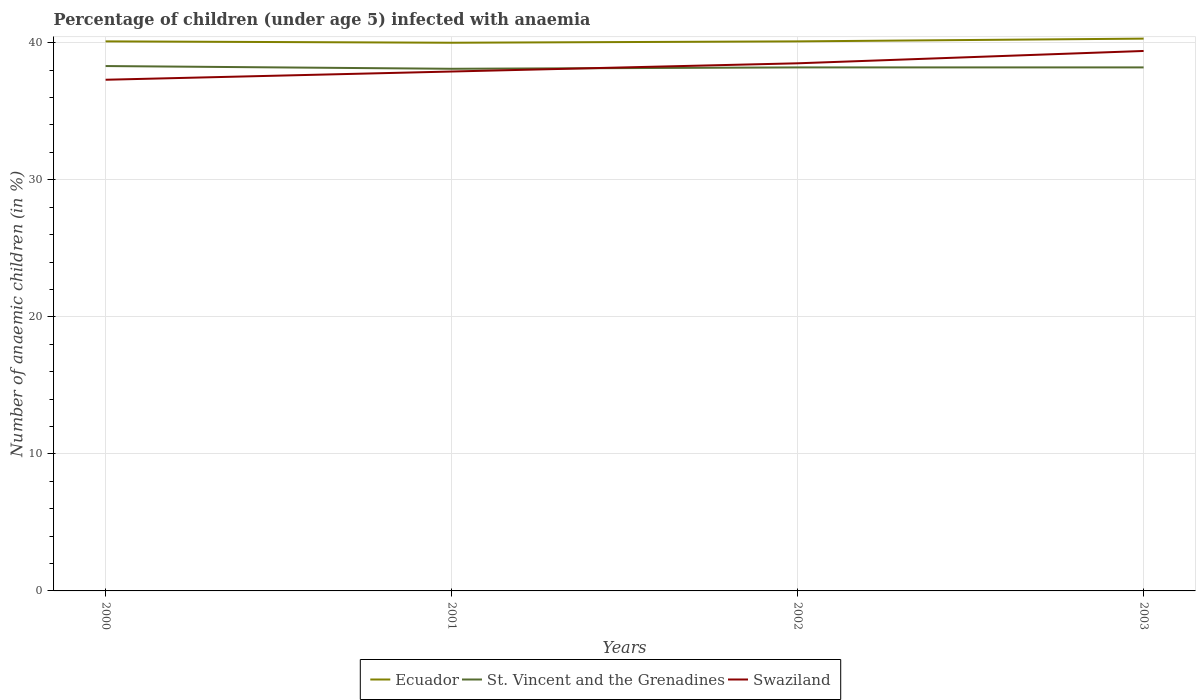Does the line corresponding to St. Vincent and the Grenadines intersect with the line corresponding to Swaziland?
Provide a short and direct response. Yes. Is the number of lines equal to the number of legend labels?
Provide a succinct answer. Yes. Across all years, what is the maximum percentage of children infected with anaemia in in St. Vincent and the Grenadines?
Ensure brevity in your answer.  38.1. In which year was the percentage of children infected with anaemia in in Ecuador maximum?
Provide a short and direct response. 2001. What is the total percentage of children infected with anaemia in in Swaziland in the graph?
Provide a short and direct response. -1.2. What is the difference between the highest and the second highest percentage of children infected with anaemia in in St. Vincent and the Grenadines?
Provide a short and direct response. 0.2. What is the difference between the highest and the lowest percentage of children infected with anaemia in in Ecuador?
Your answer should be very brief. 1. How many lines are there?
Make the answer very short. 3. Are the values on the major ticks of Y-axis written in scientific E-notation?
Offer a terse response. No. How many legend labels are there?
Ensure brevity in your answer.  3. How are the legend labels stacked?
Your response must be concise. Horizontal. What is the title of the graph?
Keep it short and to the point. Percentage of children (under age 5) infected with anaemia. What is the label or title of the Y-axis?
Provide a short and direct response. Number of anaemic children (in %). What is the Number of anaemic children (in %) of Ecuador in 2000?
Give a very brief answer. 40.1. What is the Number of anaemic children (in %) in St. Vincent and the Grenadines in 2000?
Offer a very short reply. 38.3. What is the Number of anaemic children (in %) of Swaziland in 2000?
Your answer should be very brief. 37.3. What is the Number of anaemic children (in %) of St. Vincent and the Grenadines in 2001?
Provide a succinct answer. 38.1. What is the Number of anaemic children (in %) of Swaziland in 2001?
Ensure brevity in your answer.  37.9. What is the Number of anaemic children (in %) in Ecuador in 2002?
Your answer should be compact. 40.1. What is the Number of anaemic children (in %) in St. Vincent and the Grenadines in 2002?
Offer a terse response. 38.2. What is the Number of anaemic children (in %) of Swaziland in 2002?
Make the answer very short. 38.5. What is the Number of anaemic children (in %) in Ecuador in 2003?
Make the answer very short. 40.3. What is the Number of anaemic children (in %) of St. Vincent and the Grenadines in 2003?
Your response must be concise. 38.2. What is the Number of anaemic children (in %) in Swaziland in 2003?
Your response must be concise. 39.4. Across all years, what is the maximum Number of anaemic children (in %) in Ecuador?
Offer a very short reply. 40.3. Across all years, what is the maximum Number of anaemic children (in %) of St. Vincent and the Grenadines?
Your answer should be very brief. 38.3. Across all years, what is the maximum Number of anaemic children (in %) in Swaziland?
Provide a succinct answer. 39.4. Across all years, what is the minimum Number of anaemic children (in %) of St. Vincent and the Grenadines?
Ensure brevity in your answer.  38.1. Across all years, what is the minimum Number of anaemic children (in %) of Swaziland?
Ensure brevity in your answer.  37.3. What is the total Number of anaemic children (in %) in Ecuador in the graph?
Offer a very short reply. 160.5. What is the total Number of anaemic children (in %) in St. Vincent and the Grenadines in the graph?
Your answer should be compact. 152.8. What is the total Number of anaemic children (in %) of Swaziland in the graph?
Offer a terse response. 153.1. What is the difference between the Number of anaemic children (in %) in Swaziland in 2000 and that in 2002?
Your answer should be very brief. -1.2. What is the difference between the Number of anaemic children (in %) in St. Vincent and the Grenadines in 2000 and that in 2003?
Provide a succinct answer. 0.1. What is the difference between the Number of anaemic children (in %) of Swaziland in 2000 and that in 2003?
Give a very brief answer. -2.1. What is the difference between the Number of anaemic children (in %) of Ecuador in 2001 and that in 2002?
Your answer should be compact. -0.1. What is the difference between the Number of anaemic children (in %) in Swaziland in 2001 and that in 2002?
Give a very brief answer. -0.6. What is the difference between the Number of anaemic children (in %) in Ecuador in 2002 and that in 2003?
Give a very brief answer. -0.2. What is the difference between the Number of anaemic children (in %) of Ecuador in 2000 and the Number of anaemic children (in %) of Swaziland in 2001?
Ensure brevity in your answer.  2.2. What is the difference between the Number of anaemic children (in %) of Ecuador in 2000 and the Number of anaemic children (in %) of St. Vincent and the Grenadines in 2002?
Your answer should be very brief. 1.9. What is the difference between the Number of anaemic children (in %) in Ecuador in 2001 and the Number of anaemic children (in %) in St. Vincent and the Grenadines in 2002?
Offer a terse response. 1.8. What is the difference between the Number of anaemic children (in %) in Ecuador in 2001 and the Number of anaemic children (in %) in Swaziland in 2002?
Your response must be concise. 1.5. What is the difference between the Number of anaemic children (in %) in St. Vincent and the Grenadines in 2001 and the Number of anaemic children (in %) in Swaziland in 2002?
Provide a short and direct response. -0.4. What is the difference between the Number of anaemic children (in %) in Ecuador in 2001 and the Number of anaemic children (in %) in St. Vincent and the Grenadines in 2003?
Offer a very short reply. 1.8. What is the difference between the Number of anaemic children (in %) in Ecuador in 2001 and the Number of anaemic children (in %) in Swaziland in 2003?
Your response must be concise. 0.6. What is the difference between the Number of anaemic children (in %) of Ecuador in 2002 and the Number of anaemic children (in %) of St. Vincent and the Grenadines in 2003?
Your answer should be very brief. 1.9. What is the difference between the Number of anaemic children (in %) of Ecuador in 2002 and the Number of anaemic children (in %) of Swaziland in 2003?
Ensure brevity in your answer.  0.7. What is the average Number of anaemic children (in %) in Ecuador per year?
Ensure brevity in your answer.  40.12. What is the average Number of anaemic children (in %) in St. Vincent and the Grenadines per year?
Provide a short and direct response. 38.2. What is the average Number of anaemic children (in %) of Swaziland per year?
Keep it short and to the point. 38.27. In the year 2000, what is the difference between the Number of anaemic children (in %) of Ecuador and Number of anaemic children (in %) of St. Vincent and the Grenadines?
Make the answer very short. 1.8. In the year 2001, what is the difference between the Number of anaemic children (in %) of Ecuador and Number of anaemic children (in %) of St. Vincent and the Grenadines?
Give a very brief answer. 1.9. In the year 2001, what is the difference between the Number of anaemic children (in %) in St. Vincent and the Grenadines and Number of anaemic children (in %) in Swaziland?
Make the answer very short. 0.2. In the year 2002, what is the difference between the Number of anaemic children (in %) in Ecuador and Number of anaemic children (in %) in Swaziland?
Offer a terse response. 1.6. In the year 2002, what is the difference between the Number of anaemic children (in %) of St. Vincent and the Grenadines and Number of anaemic children (in %) of Swaziland?
Offer a terse response. -0.3. In the year 2003, what is the difference between the Number of anaemic children (in %) of Ecuador and Number of anaemic children (in %) of Swaziland?
Keep it short and to the point. 0.9. In the year 2003, what is the difference between the Number of anaemic children (in %) in St. Vincent and the Grenadines and Number of anaemic children (in %) in Swaziland?
Keep it short and to the point. -1.2. What is the ratio of the Number of anaemic children (in %) in Ecuador in 2000 to that in 2001?
Keep it short and to the point. 1. What is the ratio of the Number of anaemic children (in %) in Swaziland in 2000 to that in 2001?
Ensure brevity in your answer.  0.98. What is the ratio of the Number of anaemic children (in %) of Ecuador in 2000 to that in 2002?
Provide a succinct answer. 1. What is the ratio of the Number of anaemic children (in %) in Swaziland in 2000 to that in 2002?
Provide a succinct answer. 0.97. What is the ratio of the Number of anaemic children (in %) of Ecuador in 2000 to that in 2003?
Offer a very short reply. 0.99. What is the ratio of the Number of anaemic children (in %) in St. Vincent and the Grenadines in 2000 to that in 2003?
Your response must be concise. 1. What is the ratio of the Number of anaemic children (in %) in Swaziland in 2000 to that in 2003?
Ensure brevity in your answer.  0.95. What is the ratio of the Number of anaemic children (in %) in Swaziland in 2001 to that in 2002?
Keep it short and to the point. 0.98. What is the ratio of the Number of anaemic children (in %) of Ecuador in 2001 to that in 2003?
Make the answer very short. 0.99. What is the ratio of the Number of anaemic children (in %) in St. Vincent and the Grenadines in 2001 to that in 2003?
Make the answer very short. 1. What is the ratio of the Number of anaemic children (in %) in Swaziland in 2001 to that in 2003?
Provide a short and direct response. 0.96. What is the ratio of the Number of anaemic children (in %) in Ecuador in 2002 to that in 2003?
Offer a terse response. 0.99. What is the ratio of the Number of anaemic children (in %) in St. Vincent and the Grenadines in 2002 to that in 2003?
Offer a terse response. 1. What is the ratio of the Number of anaemic children (in %) of Swaziland in 2002 to that in 2003?
Provide a short and direct response. 0.98. What is the difference between the highest and the second highest Number of anaemic children (in %) of St. Vincent and the Grenadines?
Offer a terse response. 0.1. What is the difference between the highest and the lowest Number of anaemic children (in %) in Swaziland?
Offer a very short reply. 2.1. 